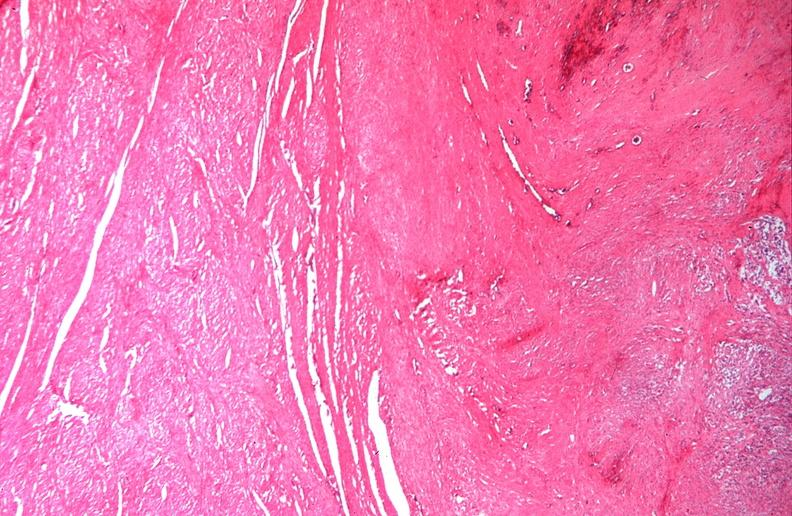does this image show uterus, leiomyomas?
Answer the question using a single word or phrase. Yes 